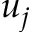<formula> <loc_0><loc_0><loc_500><loc_500>u _ { j }</formula> 